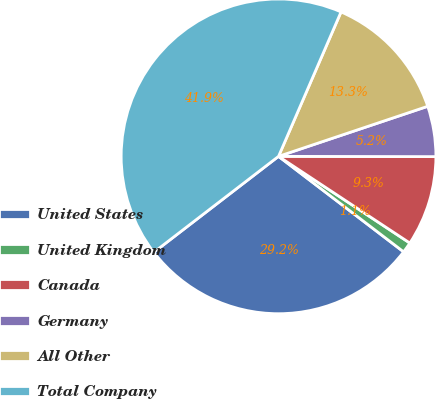<chart> <loc_0><loc_0><loc_500><loc_500><pie_chart><fcel>United States<fcel>United Kingdom<fcel>Canada<fcel>Germany<fcel>All Other<fcel>Total Company<nl><fcel>29.19%<fcel>1.09%<fcel>9.26%<fcel>5.18%<fcel>13.35%<fcel>41.94%<nl></chart> 